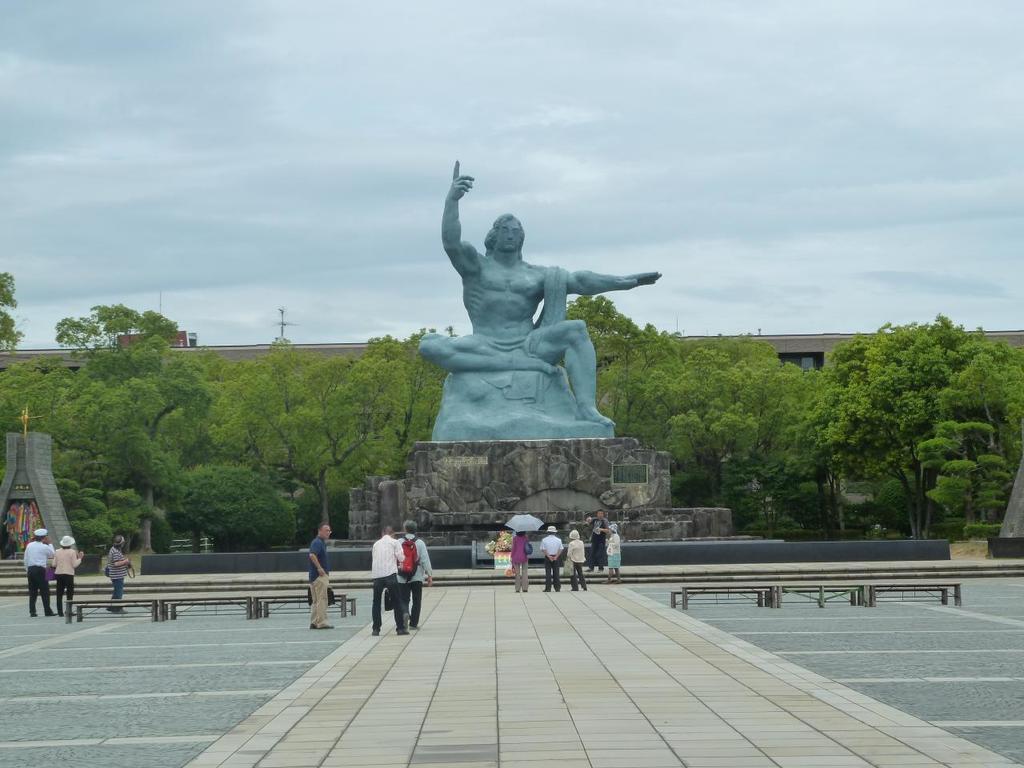Could you give a brief overview of what you see in this image? In this image we can see a statue. In the background of the image there are trees, buildings. In the foreground of the image there are people standing. There are benches. At the bottom of the image there is floor. At the top of the image there is sky. 